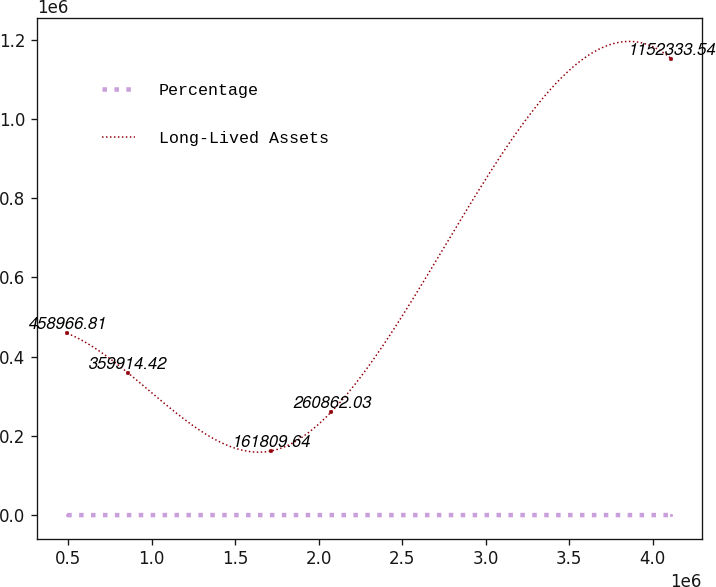Convert chart. <chart><loc_0><loc_0><loc_500><loc_500><line_chart><ecel><fcel>Percentage<fcel>Long-Lived Assets<nl><fcel>493255<fcel>40.96<fcel>458967<nl><fcel>855068<fcel>51.62<fcel>359914<nl><fcel>1.71373e+06<fcel>20<fcel>161810<nl><fcel>2.07554e+06<fcel>9.34<fcel>260862<nl><fcel>4.11138e+06<fcel>115.89<fcel>1.15233e+06<nl></chart> 